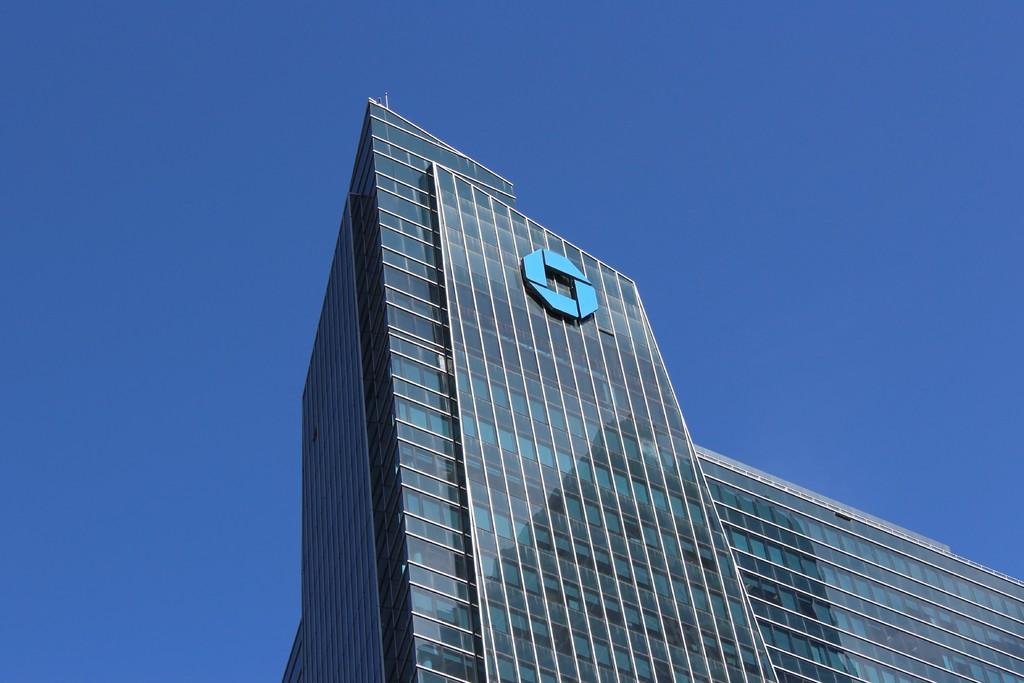What type of structure is present in the image? There is a building in the image. What can be seen above the building in the image? The sky is visible at the top of the image. How many sheep are visible in the image? There are no sheep present in the image. What type of door can be seen on the building in the image? There is no door visible on the building in the image. 